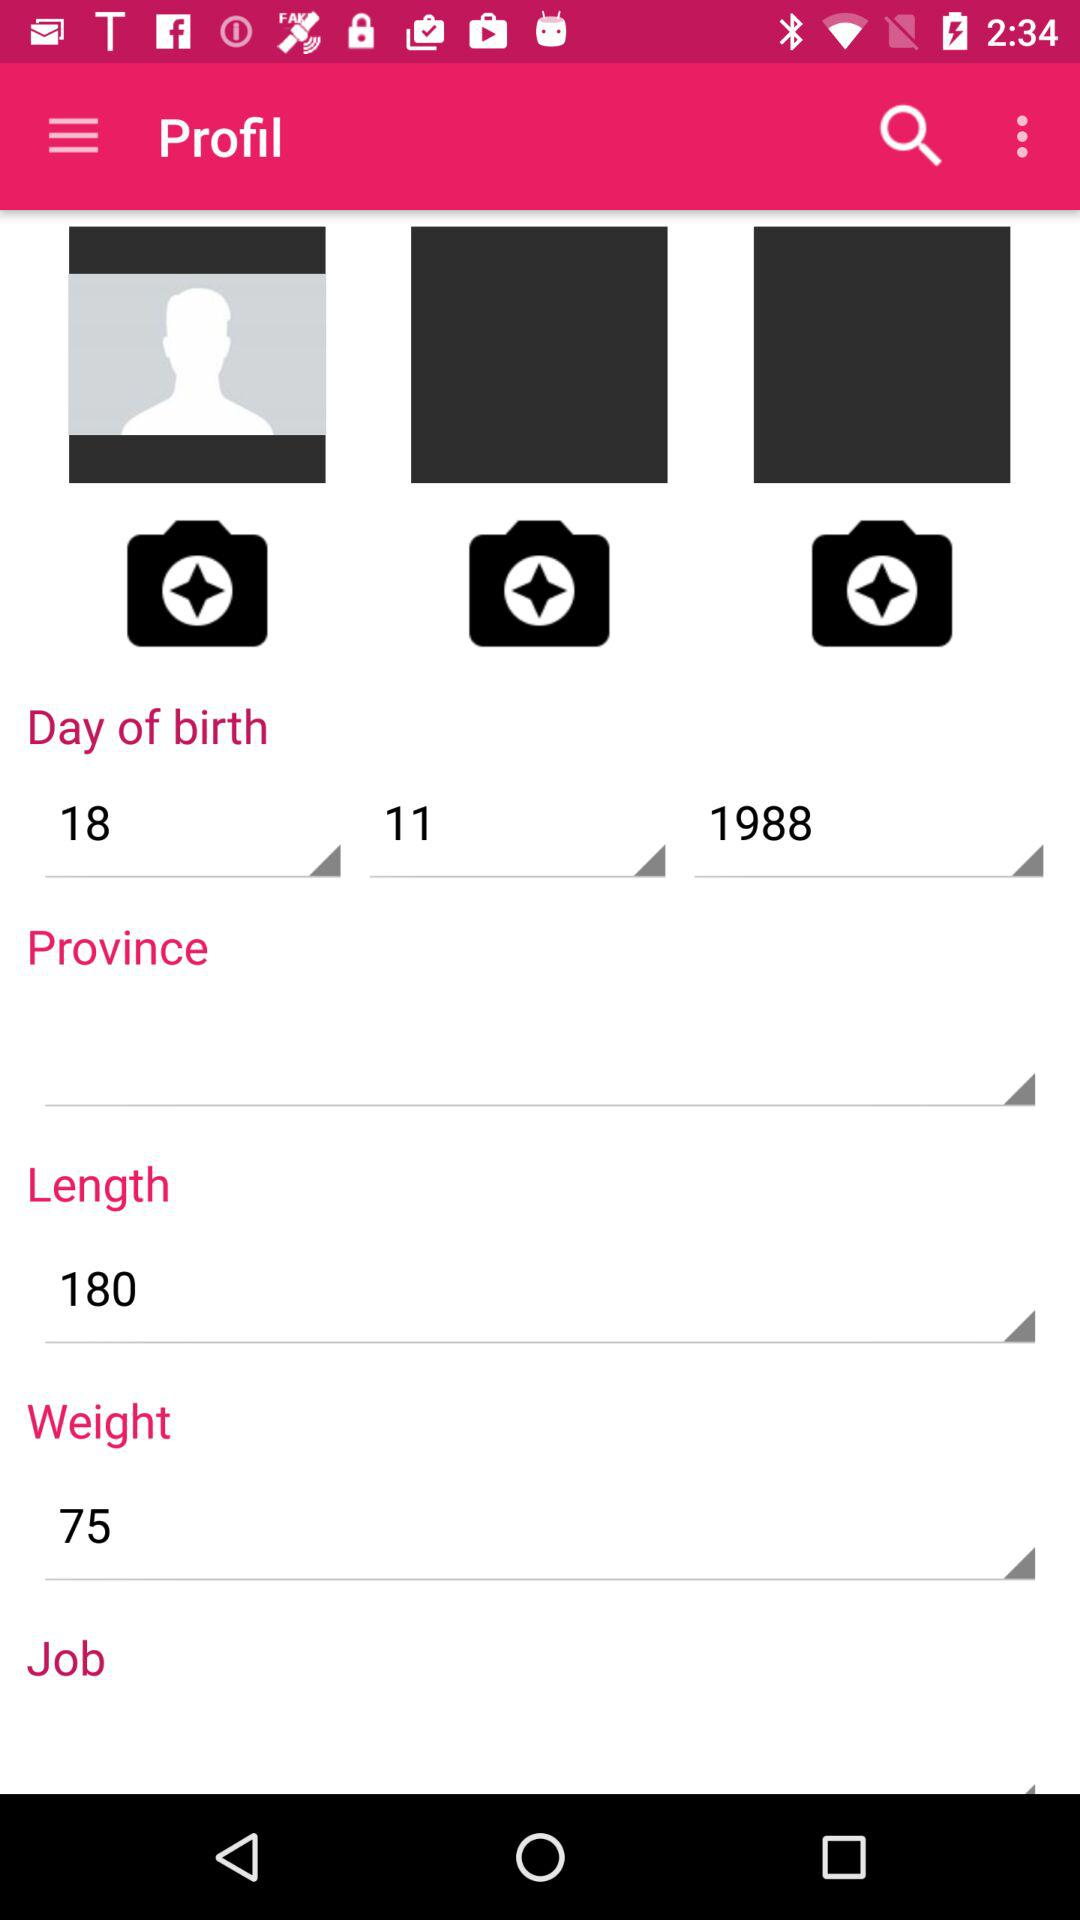How tall is the user?
When the provided information is insufficient, respond with <no answer>. <no answer> 